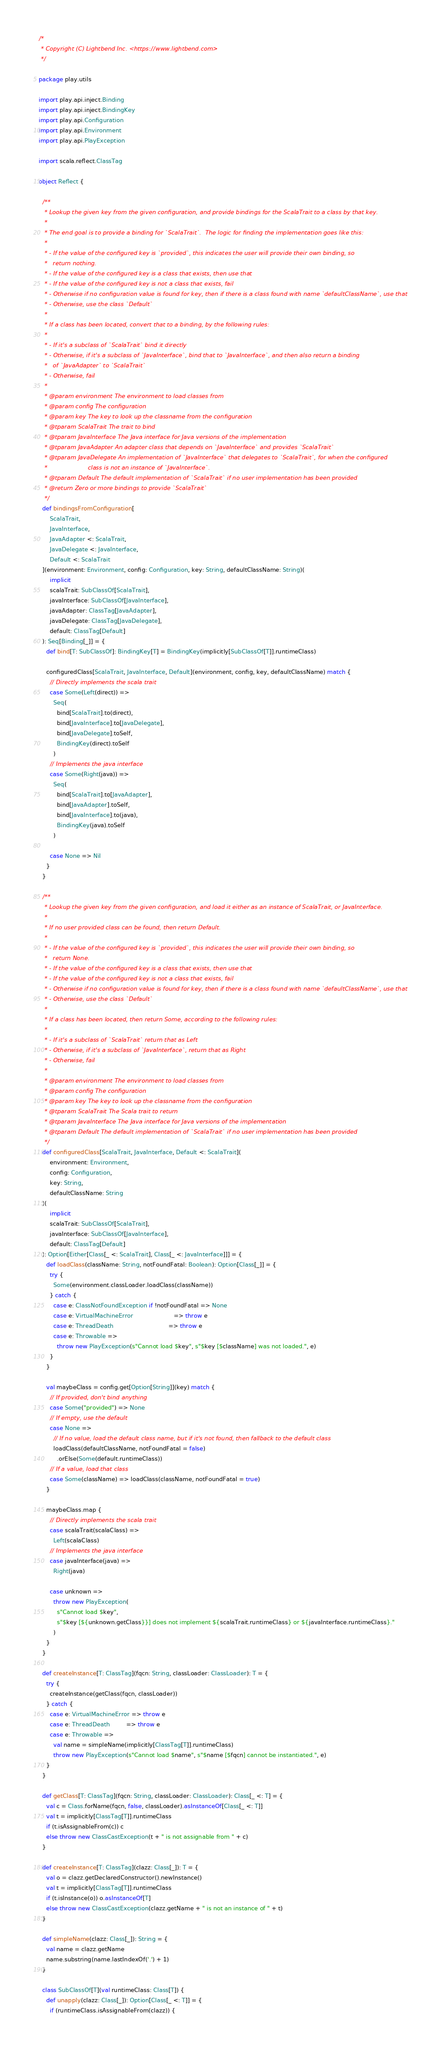Convert code to text. <code><loc_0><loc_0><loc_500><loc_500><_Scala_>/*
 * Copyright (C) Lightbend Inc. <https://www.lightbend.com>
 */

package play.utils

import play.api.inject.Binding
import play.api.inject.BindingKey
import play.api.Configuration
import play.api.Environment
import play.api.PlayException

import scala.reflect.ClassTag

object Reflect {

  /**
   * Lookup the given key from the given configuration, and provide bindings for the ScalaTrait to a class by that key.
   *
   * The end goal is to provide a binding for `ScalaTrait`.  The logic for finding the implementation goes like this:
   *
   * - If the value of the configured key is `provided`, this indicates the user will provide their own binding, so
   *   return nothing.
   * - If the value of the configured key is a class that exists, then use that
   * - If the value of the configured key is not a class that exists, fail
   * - Otherwise if no configuration value is found for key, then if there is a class found with name `defaultClassName`, use that
   * - Otherwise, use the class `Default`
   *
   * If a class has been located, convert that to a binding, by the following rules:
   *
   * - If it's a subclass of `ScalaTrait` bind it directly
   * - Otherwise, if it's a subclass of `JavaInterface`, bind that to `JavaInterface`, and then also return a binding
   *   of `JavaAdapter` to `ScalaTrait`
   * - Otherwise, fail
   *
   * @param environment The environment to load classes from
   * @param config The configuration
   * @param key The key to look up the classname from the configuration
   * @tparam ScalaTrait The trait to bind
   * @tparam JavaInterface The Java interface for Java versions of the implementation
   * @tparam JavaAdapter An adapter class that depends on `JavaInterface` and provides `ScalaTrait`
   * @tparam JavaDelegate An implementation of `JavaInterface` that delegates to `ScalaTrait`, for when the configured
   *                      class is not an instance of `JavaInterface`.
   * @tparam Default The default implementation of `ScalaTrait` if no user implementation has been provided
   * @return Zero or more bindings to provide `ScalaTrait`
   */
  def bindingsFromConfiguration[
      ScalaTrait,
      JavaInterface,
      JavaAdapter <: ScalaTrait,
      JavaDelegate <: JavaInterface,
      Default <: ScalaTrait
  ](environment: Environment, config: Configuration, key: String, defaultClassName: String)(
      implicit
      scalaTrait: SubClassOf[ScalaTrait],
      javaInterface: SubClassOf[JavaInterface],
      javaAdapter: ClassTag[JavaAdapter],
      javaDelegate: ClassTag[JavaDelegate],
      default: ClassTag[Default]
  ): Seq[Binding[_]] = {
    def bind[T: SubClassOf]: BindingKey[T] = BindingKey(implicitly[SubClassOf[T]].runtimeClass)

    configuredClass[ScalaTrait, JavaInterface, Default](environment, config, key, defaultClassName) match {
      // Directly implements the scala trait
      case Some(Left(direct)) =>
        Seq(
          bind[ScalaTrait].to(direct),
          bind[JavaInterface].to[JavaDelegate],
          bind[JavaDelegate].toSelf,
          BindingKey(direct).toSelf
        )
      // Implements the java interface
      case Some(Right(java)) =>
        Seq(
          bind[ScalaTrait].to[JavaAdapter],
          bind[JavaAdapter].toSelf,
          bind[JavaInterface].to(java),
          BindingKey(java).toSelf
        )

      case None => Nil
    }
  }

  /**
   * Lookup the given key from the given configuration, and load it either as an instance of ScalaTrait, or JavaInterface.
   *
   * If no user provided class can be found, then return Default.
   *
   * - If the value of the configured key is `provided`, this indicates the user will provide their own binding, so
   *   return None.
   * - If the value of the configured key is a class that exists, then use that
   * - If the value of the configured key is not a class that exists, fail
   * - Otherwise if no configuration value is found for key, then if there is a class found with name `defaultClassName`, use that
   * - Otherwise, use the class `Default`
   *
   * If a class has been located, then return Some, according to the following rules:
   *
   * - If it's a subclass of `ScalaTrait` return that as Left
   * - Otherwise, if it's a subclass of `JavaInterface`, return that as Right
   * - Otherwise, fail
   *
   * @param environment The environment to load classes from
   * @param config The configuration
   * @param key The key to look up the classname from the configuration
   * @tparam ScalaTrait The Scala trait to return
   * @tparam JavaInterface The Java interface for Java versions of the implementation
   * @tparam Default The default implementation of `ScalaTrait` if no user implementation has been provided
   */
  def configuredClass[ScalaTrait, JavaInterface, Default <: ScalaTrait](
      environment: Environment,
      config: Configuration,
      key: String,
      defaultClassName: String
  )(
      implicit
      scalaTrait: SubClassOf[ScalaTrait],
      javaInterface: SubClassOf[JavaInterface],
      default: ClassTag[Default]
  ): Option[Either[Class[_ <: ScalaTrait], Class[_ <: JavaInterface]]] = {
    def loadClass(className: String, notFoundFatal: Boolean): Option[Class[_]] = {
      try {
        Some(environment.classLoader.loadClass(className))
      } catch {
        case e: ClassNotFoundException if !notFoundFatal => None
        case e: VirtualMachineError                      => throw e
        case e: ThreadDeath                              => throw e
        case e: Throwable =>
          throw new PlayException(s"Cannot load $key", s"$key [$className] was not loaded.", e)
      }
    }

    val maybeClass = config.get[Option[String]](key) match {
      // If provided, don't bind anything
      case Some("provided") => None
      // If empty, use the default
      case None =>
        // If no value, load the default class name, but if it's not found, then fallback to the default class
        loadClass(defaultClassName, notFoundFatal = false)
          .orElse(Some(default.runtimeClass))
      // If a value, load that class
      case Some(className) => loadClass(className, notFoundFatal = true)
    }

    maybeClass.map {
      // Directly implements the scala trait
      case scalaTrait(scalaClass) =>
        Left(scalaClass)
      // Implements the java interface
      case javaInterface(java) =>
        Right(java)

      case unknown =>
        throw new PlayException(
          s"Cannot load $key",
          s"$key [${unknown.getClass}}] does not implement ${scalaTrait.runtimeClass} or ${javaInterface.runtimeClass}."
        )
    }
  }

  def createInstance[T: ClassTag](fqcn: String, classLoader: ClassLoader): T = {
    try {
      createInstance(getClass(fqcn, classLoader))
    } catch {
      case e: VirtualMachineError => throw e
      case e: ThreadDeath         => throw e
      case e: Throwable =>
        val name = simpleName(implicitly[ClassTag[T]].runtimeClass)
        throw new PlayException(s"Cannot load $name", s"$name [$fqcn] cannot be instantiated.", e)
    }
  }

  def getClass[T: ClassTag](fqcn: String, classLoader: ClassLoader): Class[_ <: T] = {
    val c = Class.forName(fqcn, false, classLoader).asInstanceOf[Class[_ <: T]]
    val t = implicitly[ClassTag[T]].runtimeClass
    if (t.isAssignableFrom(c)) c
    else throw new ClassCastException(t + " is not assignable from " + c)
  }

  def createInstance[T: ClassTag](clazz: Class[_]): T = {
    val o = clazz.getDeclaredConstructor().newInstance()
    val t = implicitly[ClassTag[T]].runtimeClass
    if (t.isInstance(o)) o.asInstanceOf[T]
    else throw new ClassCastException(clazz.getName + " is not an instance of " + t)
  }

  def simpleName(clazz: Class[_]): String = {
    val name = clazz.getName
    name.substring(name.lastIndexOf('.') + 1)
  }

  class SubClassOf[T](val runtimeClass: Class[T]) {
    def unapply(clazz: Class[_]): Option[Class[_ <: T]] = {
      if (runtimeClass.isAssignableFrom(clazz)) {</code> 